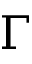Convert formula to latex. <formula><loc_0><loc_0><loc_500><loc_500>\Gamma</formula> 